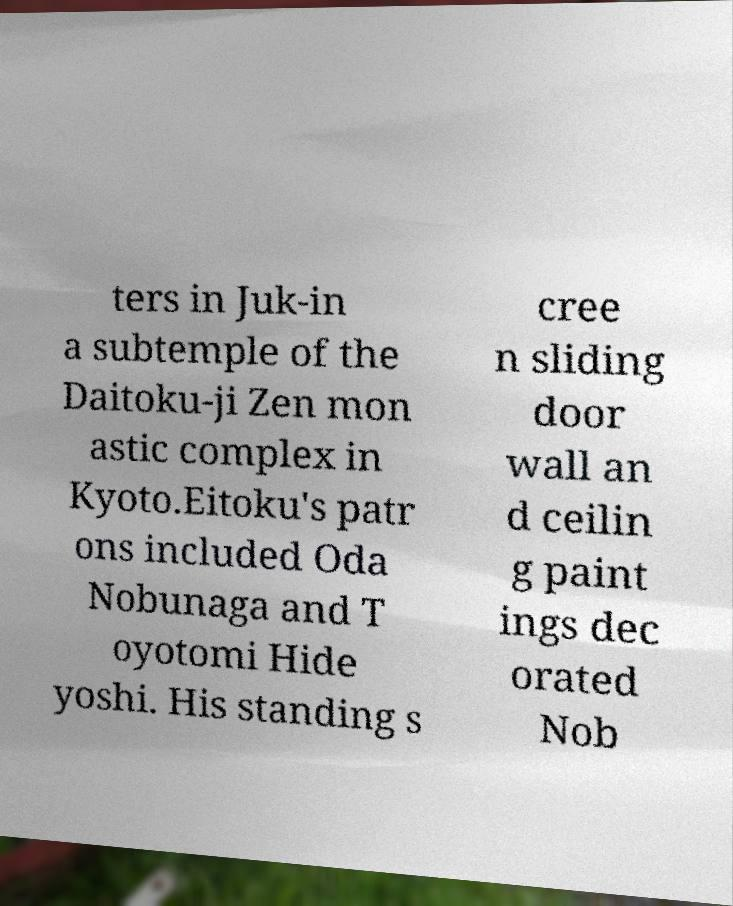Can you read and provide the text displayed in the image?This photo seems to have some interesting text. Can you extract and type it out for me? ters in Juk-in a subtemple of the Daitoku-ji Zen mon astic complex in Kyoto.Eitoku's patr ons included Oda Nobunaga and T oyotomi Hide yoshi. His standing s cree n sliding door wall an d ceilin g paint ings dec orated Nob 